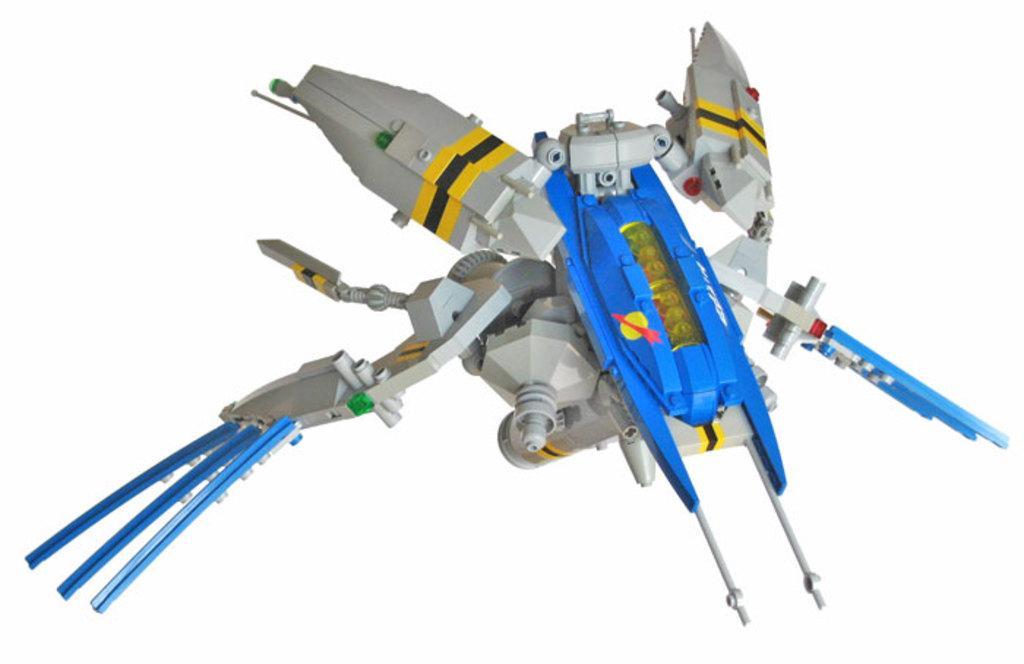Can you describe this image briefly? In this image I can see the toy which is in white, blue, yellow and black color. And I can see the white background. 